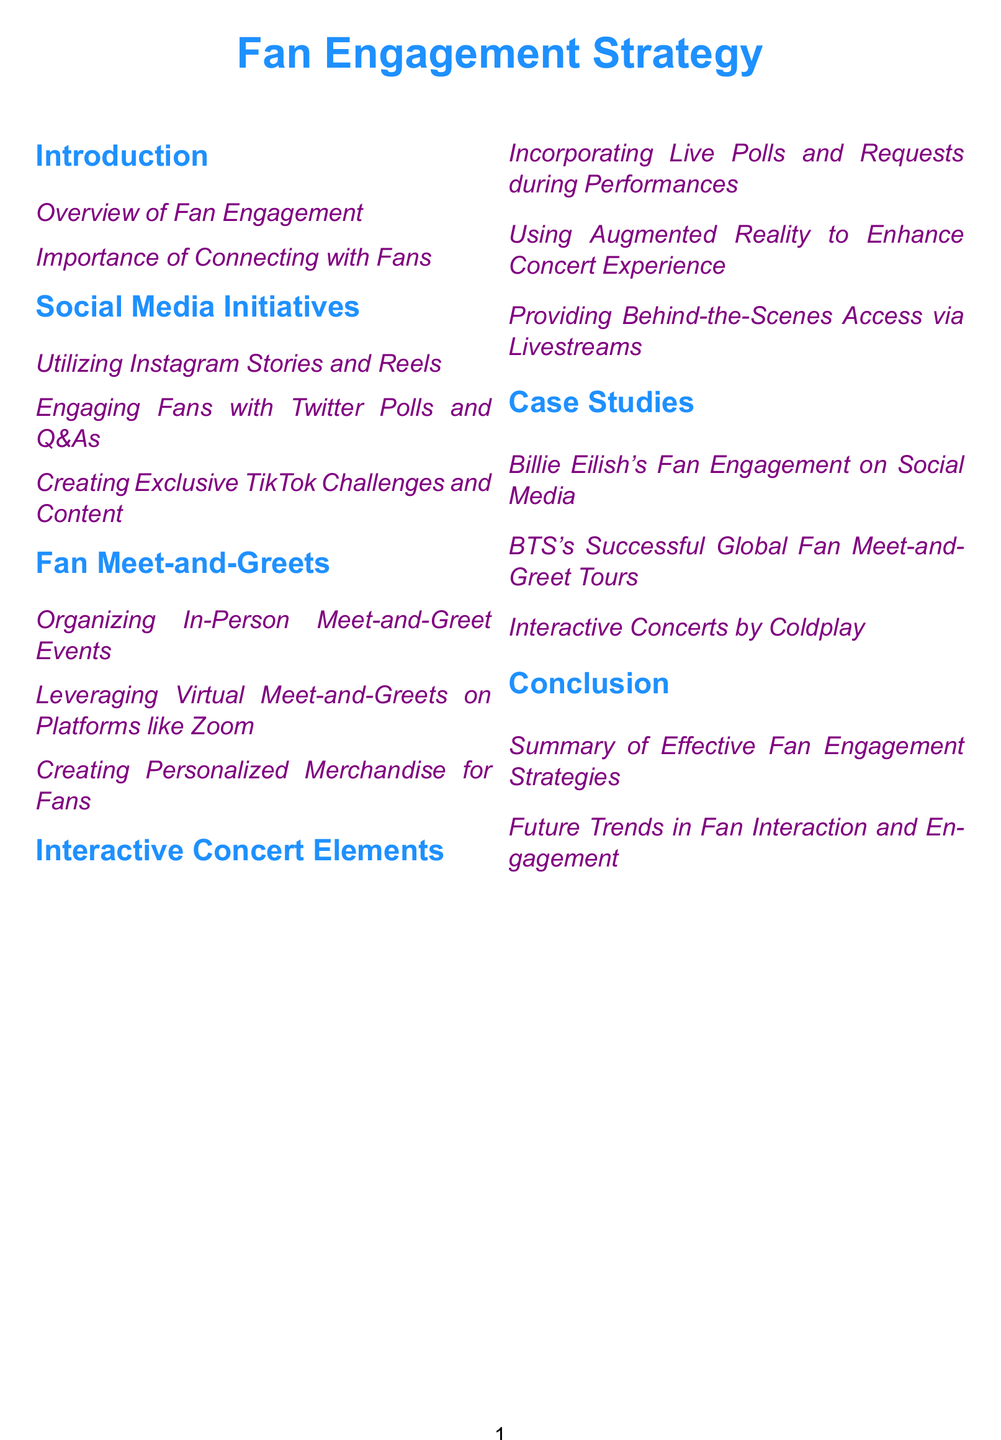what is the title of the document? The title of the document is prominently displayed at the top and is "Fan Engagement Strategy."
Answer: Fan Engagement Strategy how many main sections are in the document? The main sections are Introduction, Social Media Initiatives, Fan Meet-and-Greets, Interactive Concert Elements, Case Studies, and Conclusion, totaling six.
Answer: 6 which section covers live polls during performances? The section that covers live polls is under "Interactive Concert Elements."
Answer: Interactive Concert Elements what is one of the platforms mentioned for virtual meet-and-greets? The document specifies Zoom as a platform for virtual meet-and-greets.
Answer: Zoom who is mentioned as having successful global fan meet-and-greet tours? BTS is referenced for their successful global fan meet-and-greet tours in the case studies section.
Answer: BTS what type of content is suggested for TikTok? The document suggests creating exclusive challenges and content for TikTok.
Answer: Exclusive TikTok Challenges and Content which color is used for section titles? The section titles are formatted in music blue.
Answer: music blue what is a future trend mentioned under the conclusion? The conclusion discusses future trends in fan interaction and engagement.
Answer: Future Trends in Fan Interaction and Engagement 